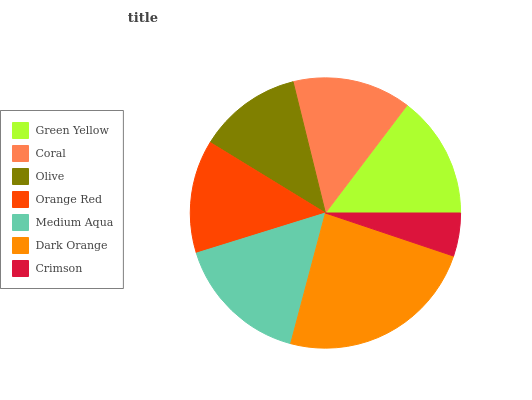Is Crimson the minimum?
Answer yes or no. Yes. Is Dark Orange the maximum?
Answer yes or no. Yes. Is Coral the minimum?
Answer yes or no. No. Is Coral the maximum?
Answer yes or no. No. Is Green Yellow greater than Coral?
Answer yes or no. Yes. Is Coral less than Green Yellow?
Answer yes or no. Yes. Is Coral greater than Green Yellow?
Answer yes or no. No. Is Green Yellow less than Coral?
Answer yes or no. No. Is Coral the high median?
Answer yes or no. Yes. Is Coral the low median?
Answer yes or no. Yes. Is Green Yellow the high median?
Answer yes or no. No. Is Orange Red the low median?
Answer yes or no. No. 